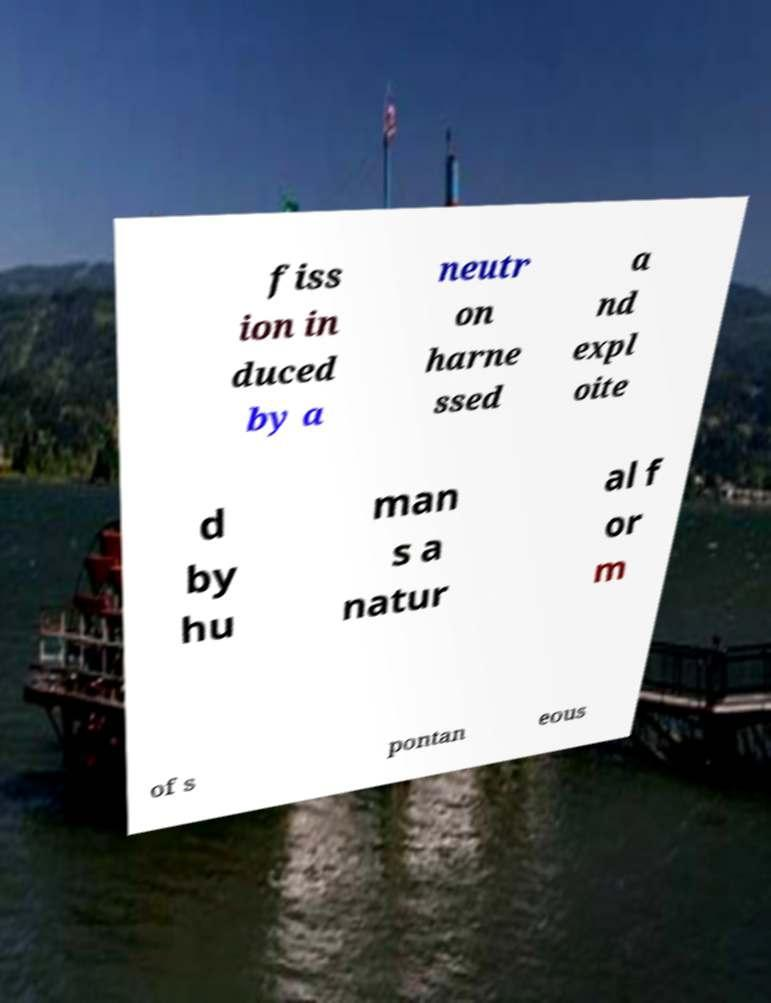Can you read and provide the text displayed in the image?This photo seems to have some interesting text. Can you extract and type it out for me? fiss ion in duced by a neutr on harne ssed a nd expl oite d by hu man s a natur al f or m of s pontan eous 